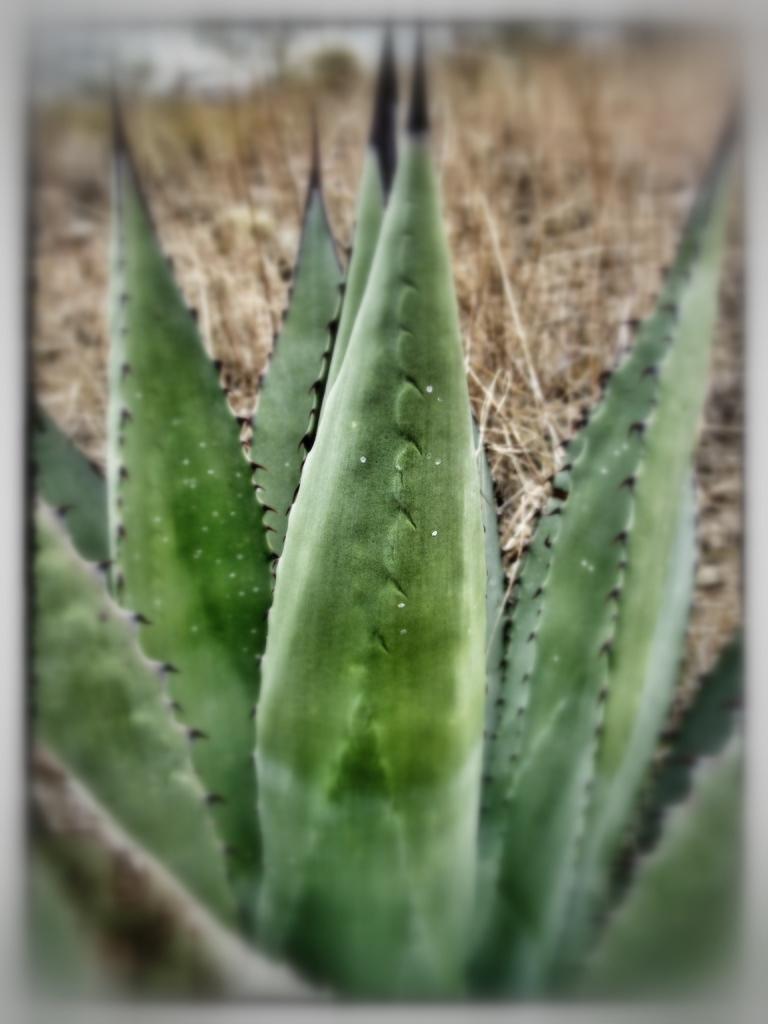Describe this image in one or two sentences. In the given image i can see a plant and behind that i can see a dry grass. 